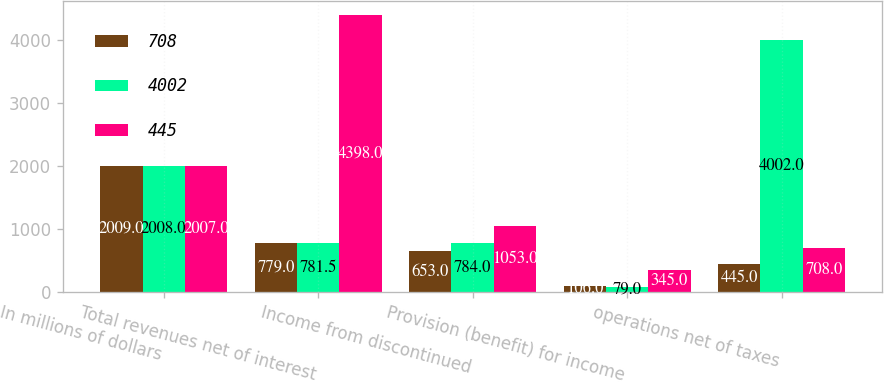<chart> <loc_0><loc_0><loc_500><loc_500><stacked_bar_chart><ecel><fcel>In millions of dollars<fcel>Total revenues net of interest<fcel>Income from discontinued<fcel>Provision (benefit) for income<fcel>operations net of taxes<nl><fcel>708<fcel>2009<fcel>779<fcel>653<fcel>106<fcel>445<nl><fcel>4002<fcel>2008<fcel>781.5<fcel>784<fcel>79<fcel>4002<nl><fcel>445<fcel>2007<fcel>4398<fcel>1053<fcel>345<fcel>708<nl></chart> 